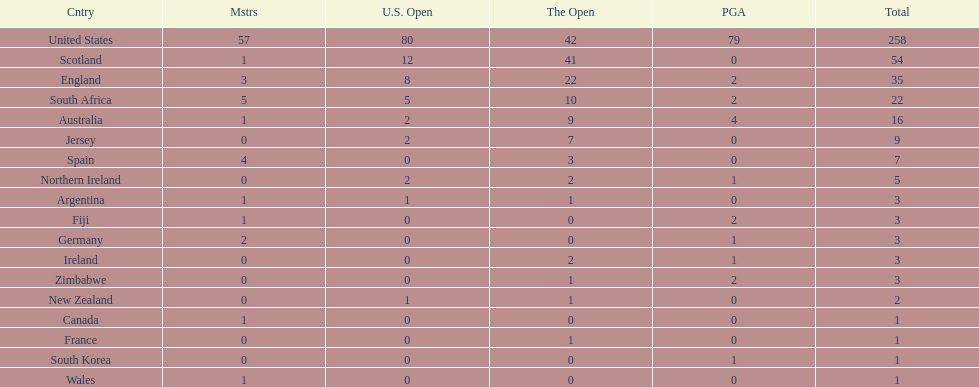How many u.s. open wins does fiji have? 0. 